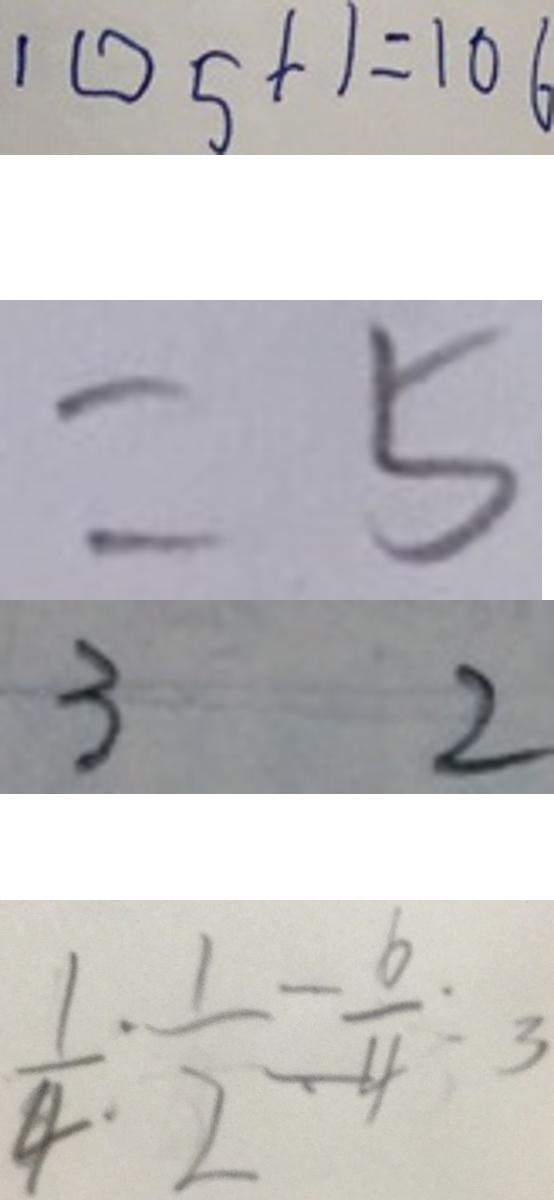<formula> <loc_0><loc_0><loc_500><loc_500>1 0 5 + 1 = 1 0 6 
 = 5 
 3 2 
 \frac { 1 } { 4 } : \frac { 1 } { 2 } = \frac { 6 } { 4 } : 3</formula> 